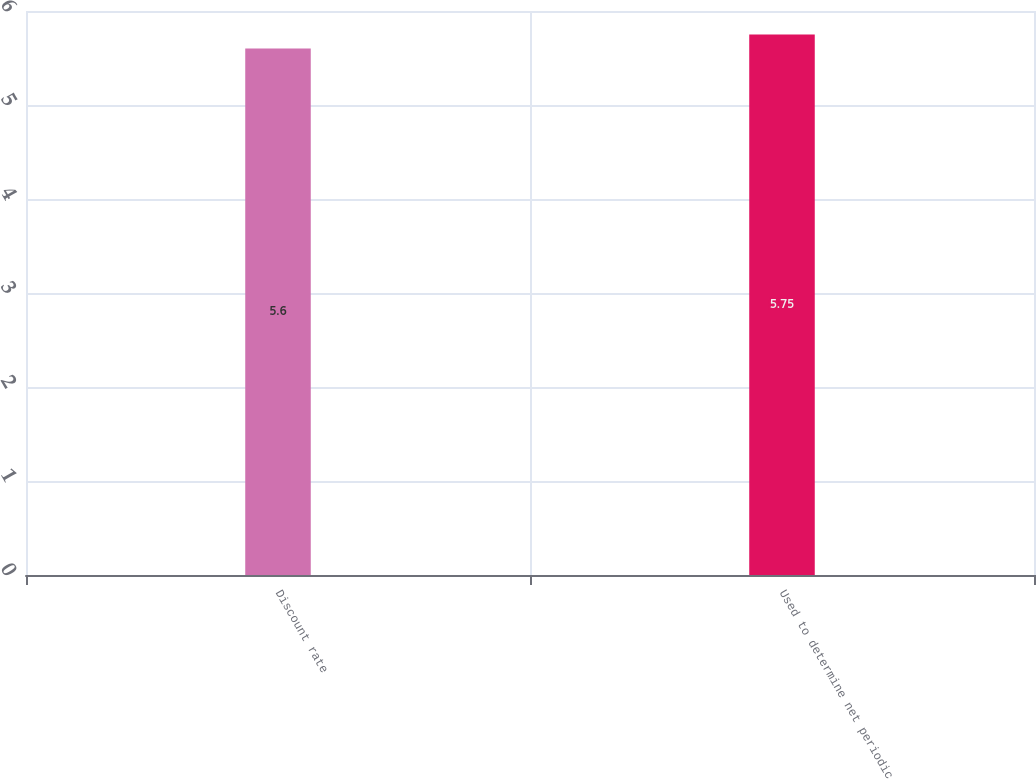Convert chart to OTSL. <chart><loc_0><loc_0><loc_500><loc_500><bar_chart><fcel>Discount rate<fcel>Used to determine net periodic<nl><fcel>5.6<fcel>5.75<nl></chart> 